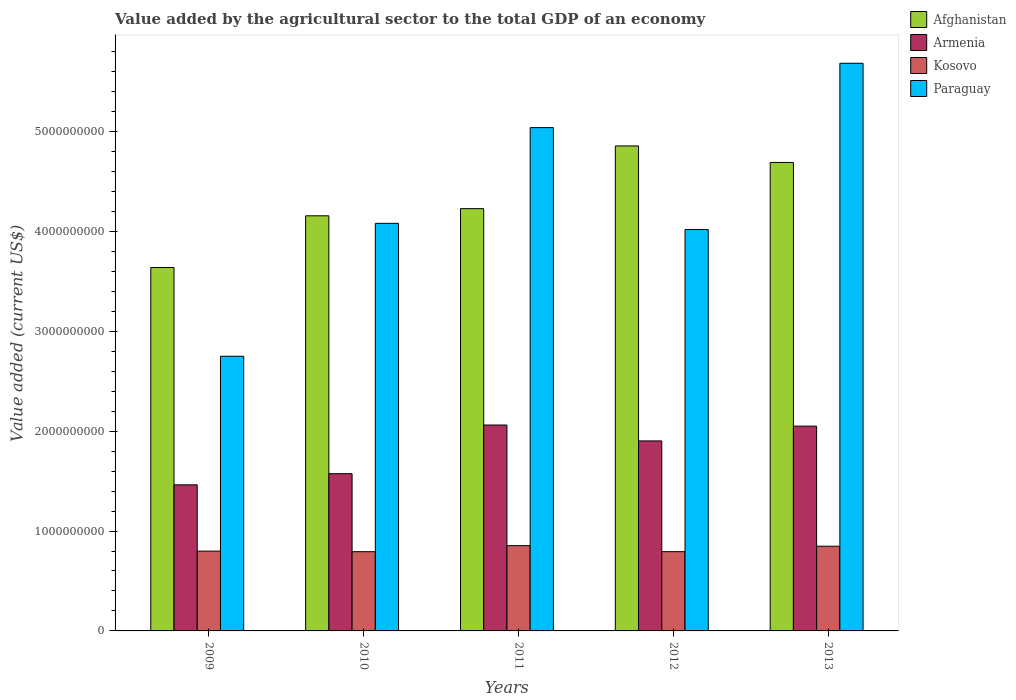How many different coloured bars are there?
Your answer should be very brief. 4. What is the value added by the agricultural sector to the total GDP in Paraguay in 2009?
Make the answer very short. 2.75e+09. Across all years, what is the maximum value added by the agricultural sector to the total GDP in Paraguay?
Provide a succinct answer. 5.68e+09. Across all years, what is the minimum value added by the agricultural sector to the total GDP in Armenia?
Provide a succinct answer. 1.46e+09. In which year was the value added by the agricultural sector to the total GDP in Paraguay minimum?
Offer a very short reply. 2009. What is the total value added by the agricultural sector to the total GDP in Afghanistan in the graph?
Your answer should be compact. 2.16e+1. What is the difference between the value added by the agricultural sector to the total GDP in Armenia in 2009 and that in 2011?
Offer a terse response. -5.99e+08. What is the difference between the value added by the agricultural sector to the total GDP in Kosovo in 2010 and the value added by the agricultural sector to the total GDP in Afghanistan in 2012?
Your answer should be very brief. -4.06e+09. What is the average value added by the agricultural sector to the total GDP in Afghanistan per year?
Offer a terse response. 4.31e+09. In the year 2011, what is the difference between the value added by the agricultural sector to the total GDP in Afghanistan and value added by the agricultural sector to the total GDP in Kosovo?
Provide a succinct answer. 3.37e+09. In how many years, is the value added by the agricultural sector to the total GDP in Armenia greater than 2400000000 US$?
Make the answer very short. 0. What is the ratio of the value added by the agricultural sector to the total GDP in Afghanistan in 2010 to that in 2012?
Offer a terse response. 0.86. Is the difference between the value added by the agricultural sector to the total GDP in Afghanistan in 2010 and 2011 greater than the difference between the value added by the agricultural sector to the total GDP in Kosovo in 2010 and 2011?
Keep it short and to the point. No. What is the difference between the highest and the second highest value added by the agricultural sector to the total GDP in Afghanistan?
Provide a succinct answer. 1.65e+08. What is the difference between the highest and the lowest value added by the agricultural sector to the total GDP in Afghanistan?
Ensure brevity in your answer.  1.22e+09. Is the sum of the value added by the agricultural sector to the total GDP in Kosovo in 2010 and 2011 greater than the maximum value added by the agricultural sector to the total GDP in Afghanistan across all years?
Your answer should be very brief. No. What does the 1st bar from the left in 2011 represents?
Offer a terse response. Afghanistan. What does the 2nd bar from the right in 2009 represents?
Provide a short and direct response. Kosovo. Are all the bars in the graph horizontal?
Offer a very short reply. No. Are the values on the major ticks of Y-axis written in scientific E-notation?
Provide a succinct answer. No. Does the graph contain any zero values?
Your response must be concise. No. Does the graph contain grids?
Offer a terse response. No. How many legend labels are there?
Give a very brief answer. 4. What is the title of the graph?
Ensure brevity in your answer.  Value added by the agricultural sector to the total GDP of an economy. What is the label or title of the Y-axis?
Your answer should be compact. Value added (current US$). What is the Value added (current US$) in Afghanistan in 2009?
Make the answer very short. 3.64e+09. What is the Value added (current US$) of Armenia in 2009?
Ensure brevity in your answer.  1.46e+09. What is the Value added (current US$) in Kosovo in 2009?
Your answer should be very brief. 7.99e+08. What is the Value added (current US$) of Paraguay in 2009?
Make the answer very short. 2.75e+09. What is the Value added (current US$) in Afghanistan in 2010?
Ensure brevity in your answer.  4.16e+09. What is the Value added (current US$) in Armenia in 2010?
Provide a short and direct response. 1.57e+09. What is the Value added (current US$) in Kosovo in 2010?
Offer a terse response. 7.93e+08. What is the Value added (current US$) of Paraguay in 2010?
Ensure brevity in your answer.  4.08e+09. What is the Value added (current US$) in Afghanistan in 2011?
Provide a succinct answer. 4.23e+09. What is the Value added (current US$) in Armenia in 2011?
Provide a short and direct response. 2.06e+09. What is the Value added (current US$) in Kosovo in 2011?
Give a very brief answer. 8.54e+08. What is the Value added (current US$) in Paraguay in 2011?
Give a very brief answer. 5.04e+09. What is the Value added (current US$) in Afghanistan in 2012?
Your answer should be compact. 4.86e+09. What is the Value added (current US$) of Armenia in 2012?
Offer a very short reply. 1.90e+09. What is the Value added (current US$) in Kosovo in 2012?
Keep it short and to the point. 7.94e+08. What is the Value added (current US$) of Paraguay in 2012?
Ensure brevity in your answer.  4.02e+09. What is the Value added (current US$) of Afghanistan in 2013?
Offer a terse response. 4.69e+09. What is the Value added (current US$) of Armenia in 2013?
Give a very brief answer. 2.05e+09. What is the Value added (current US$) of Kosovo in 2013?
Offer a terse response. 8.48e+08. What is the Value added (current US$) in Paraguay in 2013?
Your response must be concise. 5.68e+09. Across all years, what is the maximum Value added (current US$) of Afghanistan?
Give a very brief answer. 4.86e+09. Across all years, what is the maximum Value added (current US$) of Armenia?
Offer a very short reply. 2.06e+09. Across all years, what is the maximum Value added (current US$) in Kosovo?
Offer a terse response. 8.54e+08. Across all years, what is the maximum Value added (current US$) of Paraguay?
Ensure brevity in your answer.  5.68e+09. Across all years, what is the minimum Value added (current US$) of Afghanistan?
Your answer should be very brief. 3.64e+09. Across all years, what is the minimum Value added (current US$) of Armenia?
Offer a terse response. 1.46e+09. Across all years, what is the minimum Value added (current US$) of Kosovo?
Offer a very short reply. 7.93e+08. Across all years, what is the minimum Value added (current US$) of Paraguay?
Make the answer very short. 2.75e+09. What is the total Value added (current US$) of Afghanistan in the graph?
Ensure brevity in your answer.  2.16e+1. What is the total Value added (current US$) of Armenia in the graph?
Your answer should be compact. 9.05e+09. What is the total Value added (current US$) in Kosovo in the graph?
Keep it short and to the point. 4.09e+09. What is the total Value added (current US$) of Paraguay in the graph?
Your response must be concise. 2.16e+1. What is the difference between the Value added (current US$) of Afghanistan in 2009 and that in 2010?
Offer a terse response. -5.18e+08. What is the difference between the Value added (current US$) of Armenia in 2009 and that in 2010?
Keep it short and to the point. -1.12e+08. What is the difference between the Value added (current US$) of Kosovo in 2009 and that in 2010?
Make the answer very short. 6.00e+06. What is the difference between the Value added (current US$) in Paraguay in 2009 and that in 2010?
Keep it short and to the point. -1.33e+09. What is the difference between the Value added (current US$) in Afghanistan in 2009 and that in 2011?
Keep it short and to the point. -5.89e+08. What is the difference between the Value added (current US$) of Armenia in 2009 and that in 2011?
Provide a succinct answer. -5.99e+08. What is the difference between the Value added (current US$) of Kosovo in 2009 and that in 2011?
Your response must be concise. -5.48e+07. What is the difference between the Value added (current US$) in Paraguay in 2009 and that in 2011?
Provide a succinct answer. -2.29e+09. What is the difference between the Value added (current US$) of Afghanistan in 2009 and that in 2012?
Offer a very short reply. -1.22e+09. What is the difference between the Value added (current US$) of Armenia in 2009 and that in 2012?
Offer a terse response. -4.40e+08. What is the difference between the Value added (current US$) of Kosovo in 2009 and that in 2012?
Your answer should be very brief. 5.59e+06. What is the difference between the Value added (current US$) in Paraguay in 2009 and that in 2012?
Your answer should be very brief. -1.27e+09. What is the difference between the Value added (current US$) in Afghanistan in 2009 and that in 2013?
Make the answer very short. -1.05e+09. What is the difference between the Value added (current US$) in Armenia in 2009 and that in 2013?
Your response must be concise. -5.88e+08. What is the difference between the Value added (current US$) in Kosovo in 2009 and that in 2013?
Provide a short and direct response. -4.89e+07. What is the difference between the Value added (current US$) of Paraguay in 2009 and that in 2013?
Your response must be concise. -2.93e+09. What is the difference between the Value added (current US$) in Afghanistan in 2010 and that in 2011?
Ensure brevity in your answer.  -7.15e+07. What is the difference between the Value added (current US$) in Armenia in 2010 and that in 2011?
Your response must be concise. -4.87e+08. What is the difference between the Value added (current US$) in Kosovo in 2010 and that in 2011?
Offer a very short reply. -6.08e+07. What is the difference between the Value added (current US$) of Paraguay in 2010 and that in 2011?
Give a very brief answer. -9.58e+08. What is the difference between the Value added (current US$) in Afghanistan in 2010 and that in 2012?
Ensure brevity in your answer.  -7.00e+08. What is the difference between the Value added (current US$) of Armenia in 2010 and that in 2012?
Your answer should be very brief. -3.28e+08. What is the difference between the Value added (current US$) in Kosovo in 2010 and that in 2012?
Your response must be concise. -4.12e+05. What is the difference between the Value added (current US$) of Paraguay in 2010 and that in 2012?
Provide a succinct answer. 6.20e+07. What is the difference between the Value added (current US$) in Afghanistan in 2010 and that in 2013?
Your answer should be compact. -5.34e+08. What is the difference between the Value added (current US$) in Armenia in 2010 and that in 2013?
Ensure brevity in your answer.  -4.76e+08. What is the difference between the Value added (current US$) of Kosovo in 2010 and that in 2013?
Your response must be concise. -5.49e+07. What is the difference between the Value added (current US$) of Paraguay in 2010 and that in 2013?
Provide a succinct answer. -1.60e+09. What is the difference between the Value added (current US$) of Afghanistan in 2011 and that in 2012?
Provide a succinct answer. -6.28e+08. What is the difference between the Value added (current US$) in Armenia in 2011 and that in 2012?
Keep it short and to the point. 1.59e+08. What is the difference between the Value added (current US$) of Kosovo in 2011 and that in 2012?
Offer a very short reply. 6.04e+07. What is the difference between the Value added (current US$) of Paraguay in 2011 and that in 2012?
Make the answer very short. 1.02e+09. What is the difference between the Value added (current US$) in Afghanistan in 2011 and that in 2013?
Offer a terse response. -4.63e+08. What is the difference between the Value added (current US$) of Armenia in 2011 and that in 2013?
Give a very brief answer. 1.12e+07. What is the difference between the Value added (current US$) of Kosovo in 2011 and that in 2013?
Keep it short and to the point. 5.92e+06. What is the difference between the Value added (current US$) of Paraguay in 2011 and that in 2013?
Make the answer very short. -6.44e+08. What is the difference between the Value added (current US$) of Afghanistan in 2012 and that in 2013?
Keep it short and to the point. 1.65e+08. What is the difference between the Value added (current US$) of Armenia in 2012 and that in 2013?
Your answer should be compact. -1.48e+08. What is the difference between the Value added (current US$) in Kosovo in 2012 and that in 2013?
Provide a succinct answer. -5.45e+07. What is the difference between the Value added (current US$) in Paraguay in 2012 and that in 2013?
Ensure brevity in your answer.  -1.66e+09. What is the difference between the Value added (current US$) in Afghanistan in 2009 and the Value added (current US$) in Armenia in 2010?
Offer a terse response. 2.06e+09. What is the difference between the Value added (current US$) of Afghanistan in 2009 and the Value added (current US$) of Kosovo in 2010?
Make the answer very short. 2.85e+09. What is the difference between the Value added (current US$) of Afghanistan in 2009 and the Value added (current US$) of Paraguay in 2010?
Offer a terse response. -4.42e+08. What is the difference between the Value added (current US$) of Armenia in 2009 and the Value added (current US$) of Kosovo in 2010?
Your response must be concise. 6.69e+08. What is the difference between the Value added (current US$) of Armenia in 2009 and the Value added (current US$) of Paraguay in 2010?
Offer a terse response. -2.62e+09. What is the difference between the Value added (current US$) in Kosovo in 2009 and the Value added (current US$) in Paraguay in 2010?
Make the answer very short. -3.28e+09. What is the difference between the Value added (current US$) in Afghanistan in 2009 and the Value added (current US$) in Armenia in 2011?
Your answer should be compact. 1.58e+09. What is the difference between the Value added (current US$) of Afghanistan in 2009 and the Value added (current US$) of Kosovo in 2011?
Ensure brevity in your answer.  2.78e+09. What is the difference between the Value added (current US$) of Afghanistan in 2009 and the Value added (current US$) of Paraguay in 2011?
Make the answer very short. -1.40e+09. What is the difference between the Value added (current US$) in Armenia in 2009 and the Value added (current US$) in Kosovo in 2011?
Provide a succinct answer. 6.09e+08. What is the difference between the Value added (current US$) of Armenia in 2009 and the Value added (current US$) of Paraguay in 2011?
Your answer should be compact. -3.58e+09. What is the difference between the Value added (current US$) in Kosovo in 2009 and the Value added (current US$) in Paraguay in 2011?
Ensure brevity in your answer.  -4.24e+09. What is the difference between the Value added (current US$) in Afghanistan in 2009 and the Value added (current US$) in Armenia in 2012?
Provide a succinct answer. 1.74e+09. What is the difference between the Value added (current US$) of Afghanistan in 2009 and the Value added (current US$) of Kosovo in 2012?
Your response must be concise. 2.84e+09. What is the difference between the Value added (current US$) of Afghanistan in 2009 and the Value added (current US$) of Paraguay in 2012?
Give a very brief answer. -3.80e+08. What is the difference between the Value added (current US$) in Armenia in 2009 and the Value added (current US$) in Kosovo in 2012?
Your response must be concise. 6.69e+08. What is the difference between the Value added (current US$) of Armenia in 2009 and the Value added (current US$) of Paraguay in 2012?
Your response must be concise. -2.56e+09. What is the difference between the Value added (current US$) in Kosovo in 2009 and the Value added (current US$) in Paraguay in 2012?
Offer a very short reply. -3.22e+09. What is the difference between the Value added (current US$) in Afghanistan in 2009 and the Value added (current US$) in Armenia in 2013?
Offer a very short reply. 1.59e+09. What is the difference between the Value added (current US$) of Afghanistan in 2009 and the Value added (current US$) of Kosovo in 2013?
Your answer should be very brief. 2.79e+09. What is the difference between the Value added (current US$) in Afghanistan in 2009 and the Value added (current US$) in Paraguay in 2013?
Your response must be concise. -2.05e+09. What is the difference between the Value added (current US$) in Armenia in 2009 and the Value added (current US$) in Kosovo in 2013?
Keep it short and to the point. 6.15e+08. What is the difference between the Value added (current US$) in Armenia in 2009 and the Value added (current US$) in Paraguay in 2013?
Your answer should be compact. -4.22e+09. What is the difference between the Value added (current US$) of Kosovo in 2009 and the Value added (current US$) of Paraguay in 2013?
Your response must be concise. -4.88e+09. What is the difference between the Value added (current US$) in Afghanistan in 2010 and the Value added (current US$) in Armenia in 2011?
Keep it short and to the point. 2.09e+09. What is the difference between the Value added (current US$) in Afghanistan in 2010 and the Value added (current US$) in Kosovo in 2011?
Provide a short and direct response. 3.30e+09. What is the difference between the Value added (current US$) of Afghanistan in 2010 and the Value added (current US$) of Paraguay in 2011?
Make the answer very short. -8.83e+08. What is the difference between the Value added (current US$) in Armenia in 2010 and the Value added (current US$) in Kosovo in 2011?
Provide a short and direct response. 7.20e+08. What is the difference between the Value added (current US$) in Armenia in 2010 and the Value added (current US$) in Paraguay in 2011?
Ensure brevity in your answer.  -3.46e+09. What is the difference between the Value added (current US$) of Kosovo in 2010 and the Value added (current US$) of Paraguay in 2011?
Your answer should be very brief. -4.25e+09. What is the difference between the Value added (current US$) of Afghanistan in 2010 and the Value added (current US$) of Armenia in 2012?
Make the answer very short. 2.25e+09. What is the difference between the Value added (current US$) in Afghanistan in 2010 and the Value added (current US$) in Kosovo in 2012?
Your response must be concise. 3.36e+09. What is the difference between the Value added (current US$) in Afghanistan in 2010 and the Value added (current US$) in Paraguay in 2012?
Your answer should be very brief. 1.38e+08. What is the difference between the Value added (current US$) of Armenia in 2010 and the Value added (current US$) of Kosovo in 2012?
Provide a short and direct response. 7.81e+08. What is the difference between the Value added (current US$) in Armenia in 2010 and the Value added (current US$) in Paraguay in 2012?
Your answer should be compact. -2.44e+09. What is the difference between the Value added (current US$) of Kosovo in 2010 and the Value added (current US$) of Paraguay in 2012?
Your response must be concise. -3.23e+09. What is the difference between the Value added (current US$) of Afghanistan in 2010 and the Value added (current US$) of Armenia in 2013?
Offer a terse response. 2.11e+09. What is the difference between the Value added (current US$) in Afghanistan in 2010 and the Value added (current US$) in Kosovo in 2013?
Your answer should be very brief. 3.31e+09. What is the difference between the Value added (current US$) of Afghanistan in 2010 and the Value added (current US$) of Paraguay in 2013?
Provide a short and direct response. -1.53e+09. What is the difference between the Value added (current US$) of Armenia in 2010 and the Value added (current US$) of Kosovo in 2013?
Give a very brief answer. 7.26e+08. What is the difference between the Value added (current US$) of Armenia in 2010 and the Value added (current US$) of Paraguay in 2013?
Keep it short and to the point. -4.11e+09. What is the difference between the Value added (current US$) of Kosovo in 2010 and the Value added (current US$) of Paraguay in 2013?
Give a very brief answer. -4.89e+09. What is the difference between the Value added (current US$) in Afghanistan in 2011 and the Value added (current US$) in Armenia in 2012?
Make the answer very short. 2.33e+09. What is the difference between the Value added (current US$) in Afghanistan in 2011 and the Value added (current US$) in Kosovo in 2012?
Your answer should be compact. 3.43e+09. What is the difference between the Value added (current US$) of Afghanistan in 2011 and the Value added (current US$) of Paraguay in 2012?
Your answer should be very brief. 2.09e+08. What is the difference between the Value added (current US$) in Armenia in 2011 and the Value added (current US$) in Kosovo in 2012?
Your answer should be very brief. 1.27e+09. What is the difference between the Value added (current US$) of Armenia in 2011 and the Value added (current US$) of Paraguay in 2012?
Provide a succinct answer. -1.96e+09. What is the difference between the Value added (current US$) of Kosovo in 2011 and the Value added (current US$) of Paraguay in 2012?
Your answer should be compact. -3.16e+09. What is the difference between the Value added (current US$) of Afghanistan in 2011 and the Value added (current US$) of Armenia in 2013?
Keep it short and to the point. 2.18e+09. What is the difference between the Value added (current US$) in Afghanistan in 2011 and the Value added (current US$) in Kosovo in 2013?
Keep it short and to the point. 3.38e+09. What is the difference between the Value added (current US$) in Afghanistan in 2011 and the Value added (current US$) in Paraguay in 2013?
Offer a terse response. -1.46e+09. What is the difference between the Value added (current US$) of Armenia in 2011 and the Value added (current US$) of Kosovo in 2013?
Make the answer very short. 1.21e+09. What is the difference between the Value added (current US$) of Armenia in 2011 and the Value added (current US$) of Paraguay in 2013?
Your answer should be compact. -3.62e+09. What is the difference between the Value added (current US$) of Kosovo in 2011 and the Value added (current US$) of Paraguay in 2013?
Ensure brevity in your answer.  -4.83e+09. What is the difference between the Value added (current US$) in Afghanistan in 2012 and the Value added (current US$) in Armenia in 2013?
Offer a terse response. 2.81e+09. What is the difference between the Value added (current US$) of Afghanistan in 2012 and the Value added (current US$) of Kosovo in 2013?
Offer a terse response. 4.01e+09. What is the difference between the Value added (current US$) of Afghanistan in 2012 and the Value added (current US$) of Paraguay in 2013?
Your answer should be compact. -8.28e+08. What is the difference between the Value added (current US$) of Armenia in 2012 and the Value added (current US$) of Kosovo in 2013?
Ensure brevity in your answer.  1.05e+09. What is the difference between the Value added (current US$) of Armenia in 2012 and the Value added (current US$) of Paraguay in 2013?
Your answer should be compact. -3.78e+09. What is the difference between the Value added (current US$) in Kosovo in 2012 and the Value added (current US$) in Paraguay in 2013?
Your response must be concise. -4.89e+09. What is the average Value added (current US$) in Afghanistan per year?
Make the answer very short. 4.31e+09. What is the average Value added (current US$) of Armenia per year?
Ensure brevity in your answer.  1.81e+09. What is the average Value added (current US$) in Kosovo per year?
Offer a very short reply. 8.18e+08. What is the average Value added (current US$) of Paraguay per year?
Provide a short and direct response. 4.31e+09. In the year 2009, what is the difference between the Value added (current US$) of Afghanistan and Value added (current US$) of Armenia?
Provide a short and direct response. 2.18e+09. In the year 2009, what is the difference between the Value added (current US$) of Afghanistan and Value added (current US$) of Kosovo?
Give a very brief answer. 2.84e+09. In the year 2009, what is the difference between the Value added (current US$) in Afghanistan and Value added (current US$) in Paraguay?
Give a very brief answer. 8.88e+08. In the year 2009, what is the difference between the Value added (current US$) of Armenia and Value added (current US$) of Kosovo?
Your answer should be very brief. 6.63e+08. In the year 2009, what is the difference between the Value added (current US$) in Armenia and Value added (current US$) in Paraguay?
Give a very brief answer. -1.29e+09. In the year 2009, what is the difference between the Value added (current US$) of Kosovo and Value added (current US$) of Paraguay?
Your answer should be very brief. -1.95e+09. In the year 2010, what is the difference between the Value added (current US$) in Afghanistan and Value added (current US$) in Armenia?
Give a very brief answer. 2.58e+09. In the year 2010, what is the difference between the Value added (current US$) of Afghanistan and Value added (current US$) of Kosovo?
Your answer should be compact. 3.36e+09. In the year 2010, what is the difference between the Value added (current US$) in Afghanistan and Value added (current US$) in Paraguay?
Give a very brief answer. 7.56e+07. In the year 2010, what is the difference between the Value added (current US$) of Armenia and Value added (current US$) of Kosovo?
Give a very brief answer. 7.81e+08. In the year 2010, what is the difference between the Value added (current US$) of Armenia and Value added (current US$) of Paraguay?
Give a very brief answer. -2.51e+09. In the year 2010, what is the difference between the Value added (current US$) of Kosovo and Value added (current US$) of Paraguay?
Offer a very short reply. -3.29e+09. In the year 2011, what is the difference between the Value added (current US$) in Afghanistan and Value added (current US$) in Armenia?
Make the answer very short. 2.17e+09. In the year 2011, what is the difference between the Value added (current US$) in Afghanistan and Value added (current US$) in Kosovo?
Your answer should be compact. 3.37e+09. In the year 2011, what is the difference between the Value added (current US$) of Afghanistan and Value added (current US$) of Paraguay?
Offer a very short reply. -8.11e+08. In the year 2011, what is the difference between the Value added (current US$) in Armenia and Value added (current US$) in Kosovo?
Make the answer very short. 1.21e+09. In the year 2011, what is the difference between the Value added (current US$) in Armenia and Value added (current US$) in Paraguay?
Offer a very short reply. -2.98e+09. In the year 2011, what is the difference between the Value added (current US$) of Kosovo and Value added (current US$) of Paraguay?
Your answer should be very brief. -4.18e+09. In the year 2012, what is the difference between the Value added (current US$) in Afghanistan and Value added (current US$) in Armenia?
Give a very brief answer. 2.95e+09. In the year 2012, what is the difference between the Value added (current US$) of Afghanistan and Value added (current US$) of Kosovo?
Ensure brevity in your answer.  4.06e+09. In the year 2012, what is the difference between the Value added (current US$) of Afghanistan and Value added (current US$) of Paraguay?
Keep it short and to the point. 8.37e+08. In the year 2012, what is the difference between the Value added (current US$) in Armenia and Value added (current US$) in Kosovo?
Your answer should be compact. 1.11e+09. In the year 2012, what is the difference between the Value added (current US$) in Armenia and Value added (current US$) in Paraguay?
Offer a very short reply. -2.12e+09. In the year 2012, what is the difference between the Value added (current US$) of Kosovo and Value added (current US$) of Paraguay?
Your answer should be compact. -3.22e+09. In the year 2013, what is the difference between the Value added (current US$) of Afghanistan and Value added (current US$) of Armenia?
Your answer should be compact. 2.64e+09. In the year 2013, what is the difference between the Value added (current US$) in Afghanistan and Value added (current US$) in Kosovo?
Ensure brevity in your answer.  3.84e+09. In the year 2013, what is the difference between the Value added (current US$) of Afghanistan and Value added (current US$) of Paraguay?
Offer a very short reply. -9.93e+08. In the year 2013, what is the difference between the Value added (current US$) in Armenia and Value added (current US$) in Kosovo?
Provide a succinct answer. 1.20e+09. In the year 2013, what is the difference between the Value added (current US$) in Armenia and Value added (current US$) in Paraguay?
Ensure brevity in your answer.  -3.63e+09. In the year 2013, what is the difference between the Value added (current US$) in Kosovo and Value added (current US$) in Paraguay?
Offer a very short reply. -4.84e+09. What is the ratio of the Value added (current US$) in Afghanistan in 2009 to that in 2010?
Provide a succinct answer. 0.88. What is the ratio of the Value added (current US$) of Armenia in 2009 to that in 2010?
Provide a succinct answer. 0.93. What is the ratio of the Value added (current US$) of Kosovo in 2009 to that in 2010?
Provide a succinct answer. 1.01. What is the ratio of the Value added (current US$) of Paraguay in 2009 to that in 2010?
Offer a terse response. 0.67. What is the ratio of the Value added (current US$) in Afghanistan in 2009 to that in 2011?
Make the answer very short. 0.86. What is the ratio of the Value added (current US$) of Armenia in 2009 to that in 2011?
Keep it short and to the point. 0.71. What is the ratio of the Value added (current US$) of Kosovo in 2009 to that in 2011?
Your response must be concise. 0.94. What is the ratio of the Value added (current US$) of Paraguay in 2009 to that in 2011?
Provide a short and direct response. 0.55. What is the ratio of the Value added (current US$) of Afghanistan in 2009 to that in 2012?
Your response must be concise. 0.75. What is the ratio of the Value added (current US$) in Armenia in 2009 to that in 2012?
Ensure brevity in your answer.  0.77. What is the ratio of the Value added (current US$) in Kosovo in 2009 to that in 2012?
Offer a terse response. 1.01. What is the ratio of the Value added (current US$) in Paraguay in 2009 to that in 2012?
Make the answer very short. 0.68. What is the ratio of the Value added (current US$) of Afghanistan in 2009 to that in 2013?
Give a very brief answer. 0.78. What is the ratio of the Value added (current US$) of Armenia in 2009 to that in 2013?
Your response must be concise. 0.71. What is the ratio of the Value added (current US$) of Kosovo in 2009 to that in 2013?
Keep it short and to the point. 0.94. What is the ratio of the Value added (current US$) of Paraguay in 2009 to that in 2013?
Ensure brevity in your answer.  0.48. What is the ratio of the Value added (current US$) in Afghanistan in 2010 to that in 2011?
Make the answer very short. 0.98. What is the ratio of the Value added (current US$) in Armenia in 2010 to that in 2011?
Provide a succinct answer. 0.76. What is the ratio of the Value added (current US$) in Kosovo in 2010 to that in 2011?
Your response must be concise. 0.93. What is the ratio of the Value added (current US$) in Paraguay in 2010 to that in 2011?
Keep it short and to the point. 0.81. What is the ratio of the Value added (current US$) of Afghanistan in 2010 to that in 2012?
Make the answer very short. 0.86. What is the ratio of the Value added (current US$) of Armenia in 2010 to that in 2012?
Make the answer very short. 0.83. What is the ratio of the Value added (current US$) in Paraguay in 2010 to that in 2012?
Make the answer very short. 1.02. What is the ratio of the Value added (current US$) of Afghanistan in 2010 to that in 2013?
Offer a very short reply. 0.89. What is the ratio of the Value added (current US$) of Armenia in 2010 to that in 2013?
Your response must be concise. 0.77. What is the ratio of the Value added (current US$) of Kosovo in 2010 to that in 2013?
Give a very brief answer. 0.94. What is the ratio of the Value added (current US$) of Paraguay in 2010 to that in 2013?
Give a very brief answer. 0.72. What is the ratio of the Value added (current US$) in Afghanistan in 2011 to that in 2012?
Make the answer very short. 0.87. What is the ratio of the Value added (current US$) in Armenia in 2011 to that in 2012?
Offer a terse response. 1.08. What is the ratio of the Value added (current US$) of Kosovo in 2011 to that in 2012?
Your answer should be compact. 1.08. What is the ratio of the Value added (current US$) in Paraguay in 2011 to that in 2012?
Provide a short and direct response. 1.25. What is the ratio of the Value added (current US$) of Afghanistan in 2011 to that in 2013?
Offer a terse response. 0.9. What is the ratio of the Value added (current US$) of Kosovo in 2011 to that in 2013?
Your answer should be compact. 1.01. What is the ratio of the Value added (current US$) of Paraguay in 2011 to that in 2013?
Provide a short and direct response. 0.89. What is the ratio of the Value added (current US$) of Afghanistan in 2012 to that in 2013?
Your response must be concise. 1.04. What is the ratio of the Value added (current US$) in Armenia in 2012 to that in 2013?
Make the answer very short. 0.93. What is the ratio of the Value added (current US$) in Kosovo in 2012 to that in 2013?
Your answer should be very brief. 0.94. What is the ratio of the Value added (current US$) of Paraguay in 2012 to that in 2013?
Your answer should be compact. 0.71. What is the difference between the highest and the second highest Value added (current US$) in Afghanistan?
Ensure brevity in your answer.  1.65e+08. What is the difference between the highest and the second highest Value added (current US$) of Armenia?
Provide a succinct answer. 1.12e+07. What is the difference between the highest and the second highest Value added (current US$) in Kosovo?
Make the answer very short. 5.92e+06. What is the difference between the highest and the second highest Value added (current US$) of Paraguay?
Your answer should be very brief. 6.44e+08. What is the difference between the highest and the lowest Value added (current US$) in Afghanistan?
Offer a very short reply. 1.22e+09. What is the difference between the highest and the lowest Value added (current US$) of Armenia?
Provide a short and direct response. 5.99e+08. What is the difference between the highest and the lowest Value added (current US$) of Kosovo?
Provide a short and direct response. 6.08e+07. What is the difference between the highest and the lowest Value added (current US$) in Paraguay?
Provide a succinct answer. 2.93e+09. 